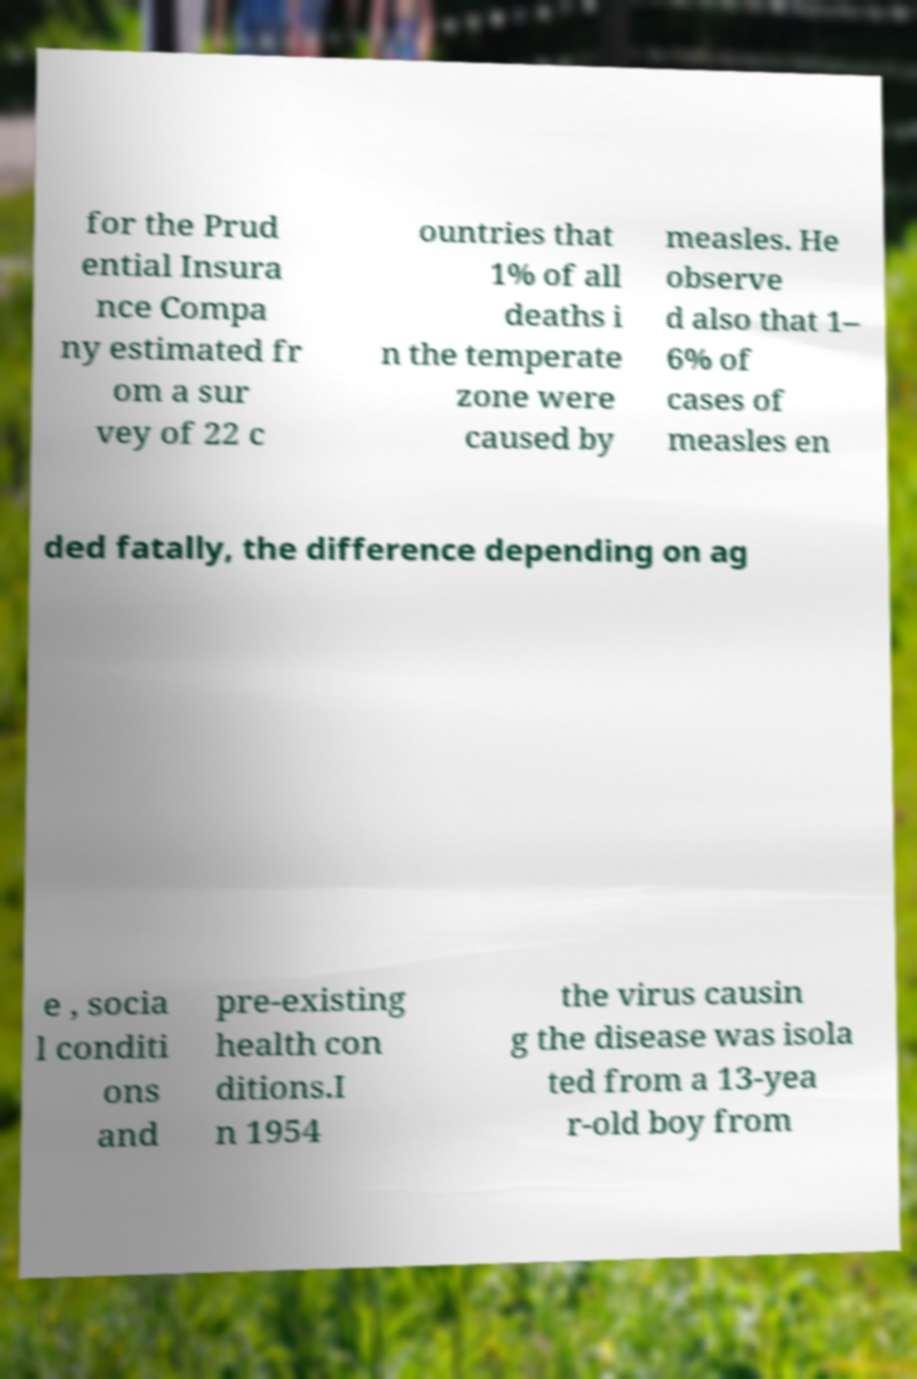Please identify and transcribe the text found in this image. for the Prud ential Insura nce Compa ny estimated fr om a sur vey of 22 c ountries that 1% of all deaths i n the temperate zone were caused by measles. He observe d also that 1– 6% of cases of measles en ded fatally, the difference depending on ag e , socia l conditi ons and pre-existing health con ditions.I n 1954 the virus causin g the disease was isola ted from a 13-yea r-old boy from 